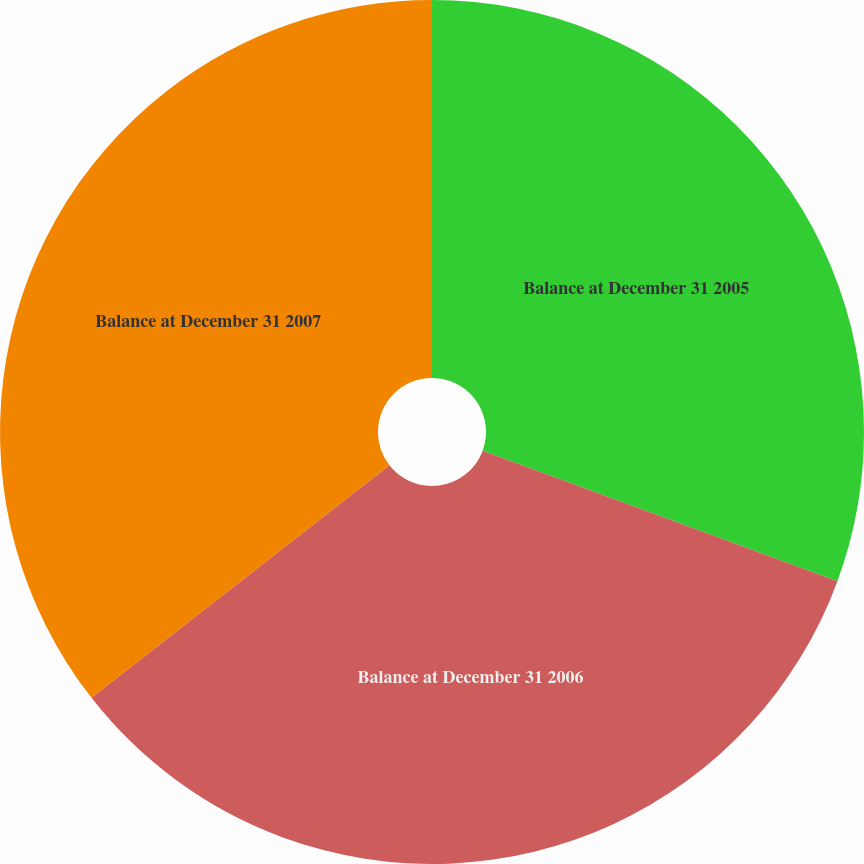Convert chart. <chart><loc_0><loc_0><loc_500><loc_500><pie_chart><fcel>Balance at December 31 2005<fcel>Balance at December 31 2006<fcel>Balance at December 31 2007<nl><fcel>30.61%<fcel>33.84%<fcel>35.55%<nl></chart> 